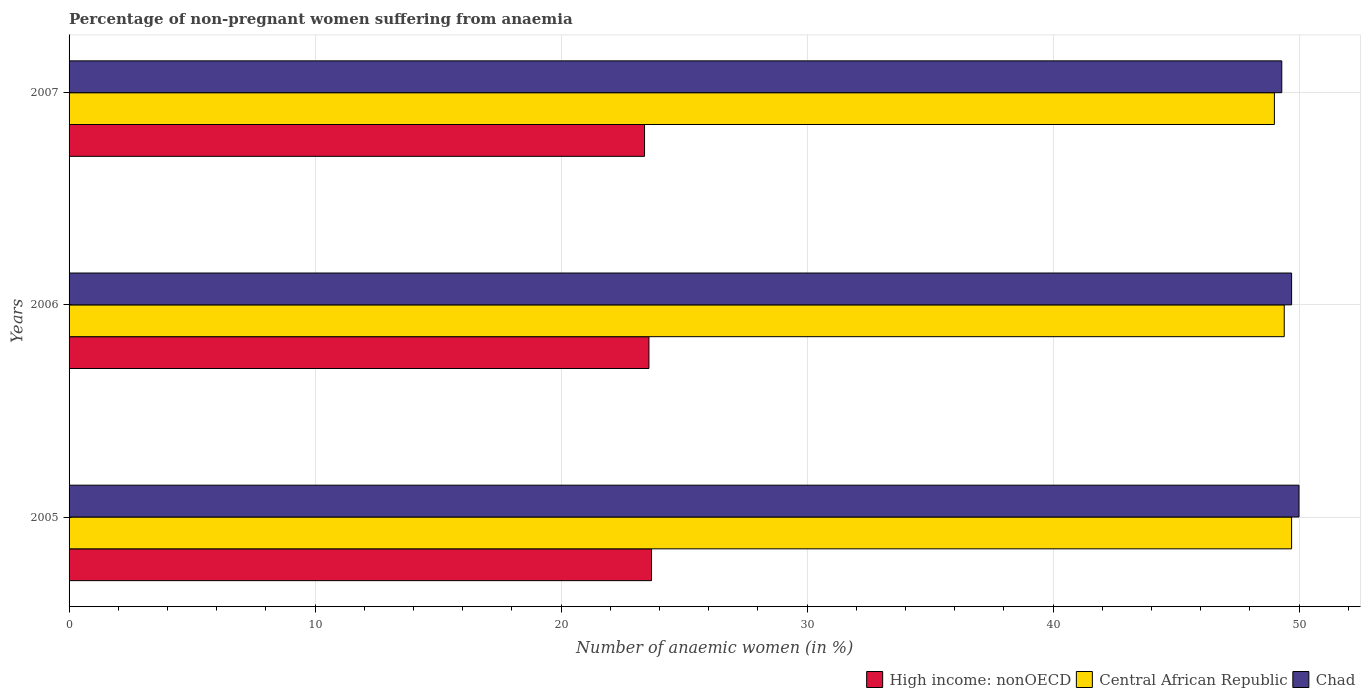How many different coloured bars are there?
Ensure brevity in your answer.  3. Are the number of bars per tick equal to the number of legend labels?
Provide a short and direct response. Yes. Are the number of bars on each tick of the Y-axis equal?
Keep it short and to the point. Yes. How many bars are there on the 1st tick from the bottom?
Provide a succinct answer. 3. What is the percentage of non-pregnant women suffering from anaemia in Chad in 2007?
Ensure brevity in your answer.  49.3. Across all years, what is the maximum percentage of non-pregnant women suffering from anaemia in Central African Republic?
Your answer should be compact. 49.7. Across all years, what is the minimum percentage of non-pregnant women suffering from anaemia in High income: nonOECD?
Ensure brevity in your answer.  23.39. What is the total percentage of non-pregnant women suffering from anaemia in Central African Republic in the graph?
Your response must be concise. 148.1. What is the difference between the percentage of non-pregnant women suffering from anaemia in High income: nonOECD in 2006 and that in 2007?
Ensure brevity in your answer.  0.18. What is the difference between the percentage of non-pregnant women suffering from anaemia in Central African Republic in 2006 and the percentage of non-pregnant women suffering from anaemia in High income: nonOECD in 2007?
Give a very brief answer. 26.01. What is the average percentage of non-pregnant women suffering from anaemia in Chad per year?
Make the answer very short. 49.67. In the year 2007, what is the difference between the percentage of non-pregnant women suffering from anaemia in Chad and percentage of non-pregnant women suffering from anaemia in High income: nonOECD?
Keep it short and to the point. 25.91. What is the ratio of the percentage of non-pregnant women suffering from anaemia in High income: nonOECD in 2005 to that in 2007?
Your answer should be compact. 1.01. What is the difference between the highest and the second highest percentage of non-pregnant women suffering from anaemia in High income: nonOECD?
Offer a terse response. 0.11. What is the difference between the highest and the lowest percentage of non-pregnant women suffering from anaemia in Central African Republic?
Keep it short and to the point. 0.7. In how many years, is the percentage of non-pregnant women suffering from anaemia in Central African Republic greater than the average percentage of non-pregnant women suffering from anaemia in Central African Republic taken over all years?
Provide a short and direct response. 2. Is the sum of the percentage of non-pregnant women suffering from anaemia in Central African Republic in 2006 and 2007 greater than the maximum percentage of non-pregnant women suffering from anaemia in High income: nonOECD across all years?
Ensure brevity in your answer.  Yes. What does the 1st bar from the top in 2005 represents?
Make the answer very short. Chad. What does the 2nd bar from the bottom in 2005 represents?
Provide a succinct answer. Central African Republic. Is it the case that in every year, the sum of the percentage of non-pregnant women suffering from anaemia in High income: nonOECD and percentage of non-pregnant women suffering from anaemia in Central African Republic is greater than the percentage of non-pregnant women suffering from anaemia in Chad?
Offer a very short reply. Yes. Are all the bars in the graph horizontal?
Offer a terse response. Yes. How many years are there in the graph?
Your response must be concise. 3. What is the difference between two consecutive major ticks on the X-axis?
Give a very brief answer. 10. How many legend labels are there?
Ensure brevity in your answer.  3. What is the title of the graph?
Ensure brevity in your answer.  Percentage of non-pregnant women suffering from anaemia. What is the label or title of the X-axis?
Offer a very short reply. Number of anaemic women (in %). What is the label or title of the Y-axis?
Your response must be concise. Years. What is the Number of anaemic women (in %) in High income: nonOECD in 2005?
Your answer should be compact. 23.68. What is the Number of anaemic women (in %) of Central African Republic in 2005?
Ensure brevity in your answer.  49.7. What is the Number of anaemic women (in %) in Chad in 2005?
Make the answer very short. 50. What is the Number of anaemic women (in %) of High income: nonOECD in 2006?
Keep it short and to the point. 23.57. What is the Number of anaemic women (in %) in Central African Republic in 2006?
Provide a succinct answer. 49.4. What is the Number of anaemic women (in %) in Chad in 2006?
Make the answer very short. 49.7. What is the Number of anaemic women (in %) in High income: nonOECD in 2007?
Ensure brevity in your answer.  23.39. What is the Number of anaemic women (in %) of Chad in 2007?
Offer a terse response. 49.3. Across all years, what is the maximum Number of anaemic women (in %) of High income: nonOECD?
Provide a short and direct response. 23.68. Across all years, what is the maximum Number of anaemic women (in %) of Central African Republic?
Offer a very short reply. 49.7. Across all years, what is the maximum Number of anaemic women (in %) in Chad?
Keep it short and to the point. 50. Across all years, what is the minimum Number of anaemic women (in %) of High income: nonOECD?
Ensure brevity in your answer.  23.39. Across all years, what is the minimum Number of anaemic women (in %) of Chad?
Your answer should be compact. 49.3. What is the total Number of anaemic women (in %) in High income: nonOECD in the graph?
Make the answer very short. 70.65. What is the total Number of anaemic women (in %) in Central African Republic in the graph?
Offer a terse response. 148.1. What is the total Number of anaemic women (in %) in Chad in the graph?
Offer a very short reply. 149. What is the difference between the Number of anaemic women (in %) in High income: nonOECD in 2005 and that in 2006?
Provide a short and direct response. 0.11. What is the difference between the Number of anaemic women (in %) in High income: nonOECD in 2005 and that in 2007?
Make the answer very short. 0.28. What is the difference between the Number of anaemic women (in %) of Chad in 2005 and that in 2007?
Offer a very short reply. 0.7. What is the difference between the Number of anaemic women (in %) in High income: nonOECD in 2006 and that in 2007?
Your answer should be very brief. 0.18. What is the difference between the Number of anaemic women (in %) in Central African Republic in 2006 and that in 2007?
Provide a succinct answer. 0.4. What is the difference between the Number of anaemic women (in %) of High income: nonOECD in 2005 and the Number of anaemic women (in %) of Central African Republic in 2006?
Provide a short and direct response. -25.72. What is the difference between the Number of anaemic women (in %) in High income: nonOECD in 2005 and the Number of anaemic women (in %) in Chad in 2006?
Your answer should be compact. -26.02. What is the difference between the Number of anaemic women (in %) in High income: nonOECD in 2005 and the Number of anaemic women (in %) in Central African Republic in 2007?
Make the answer very short. -25.32. What is the difference between the Number of anaemic women (in %) in High income: nonOECD in 2005 and the Number of anaemic women (in %) in Chad in 2007?
Keep it short and to the point. -25.62. What is the difference between the Number of anaemic women (in %) in High income: nonOECD in 2006 and the Number of anaemic women (in %) in Central African Republic in 2007?
Make the answer very short. -25.43. What is the difference between the Number of anaemic women (in %) of High income: nonOECD in 2006 and the Number of anaemic women (in %) of Chad in 2007?
Offer a very short reply. -25.73. What is the difference between the Number of anaemic women (in %) in Central African Republic in 2006 and the Number of anaemic women (in %) in Chad in 2007?
Your response must be concise. 0.1. What is the average Number of anaemic women (in %) of High income: nonOECD per year?
Your answer should be very brief. 23.55. What is the average Number of anaemic women (in %) of Central African Republic per year?
Your answer should be very brief. 49.37. What is the average Number of anaemic women (in %) in Chad per year?
Provide a short and direct response. 49.67. In the year 2005, what is the difference between the Number of anaemic women (in %) of High income: nonOECD and Number of anaemic women (in %) of Central African Republic?
Provide a short and direct response. -26.02. In the year 2005, what is the difference between the Number of anaemic women (in %) in High income: nonOECD and Number of anaemic women (in %) in Chad?
Your answer should be compact. -26.32. In the year 2005, what is the difference between the Number of anaemic women (in %) in Central African Republic and Number of anaemic women (in %) in Chad?
Provide a short and direct response. -0.3. In the year 2006, what is the difference between the Number of anaemic women (in %) in High income: nonOECD and Number of anaemic women (in %) in Central African Republic?
Offer a terse response. -25.83. In the year 2006, what is the difference between the Number of anaemic women (in %) in High income: nonOECD and Number of anaemic women (in %) in Chad?
Give a very brief answer. -26.13. In the year 2006, what is the difference between the Number of anaemic women (in %) of Central African Republic and Number of anaemic women (in %) of Chad?
Provide a short and direct response. -0.3. In the year 2007, what is the difference between the Number of anaemic women (in %) in High income: nonOECD and Number of anaemic women (in %) in Central African Republic?
Your response must be concise. -25.61. In the year 2007, what is the difference between the Number of anaemic women (in %) in High income: nonOECD and Number of anaemic women (in %) in Chad?
Offer a very short reply. -25.91. In the year 2007, what is the difference between the Number of anaemic women (in %) in Central African Republic and Number of anaemic women (in %) in Chad?
Your answer should be compact. -0.3. What is the ratio of the Number of anaemic women (in %) in High income: nonOECD in 2005 to that in 2006?
Offer a terse response. 1. What is the ratio of the Number of anaemic women (in %) of Chad in 2005 to that in 2006?
Your response must be concise. 1.01. What is the ratio of the Number of anaemic women (in %) in High income: nonOECD in 2005 to that in 2007?
Offer a terse response. 1.01. What is the ratio of the Number of anaemic women (in %) in Central African Republic in 2005 to that in 2007?
Provide a short and direct response. 1.01. What is the ratio of the Number of anaemic women (in %) of Chad in 2005 to that in 2007?
Offer a terse response. 1.01. What is the ratio of the Number of anaemic women (in %) in High income: nonOECD in 2006 to that in 2007?
Provide a succinct answer. 1.01. What is the ratio of the Number of anaemic women (in %) of Central African Republic in 2006 to that in 2007?
Your answer should be very brief. 1.01. What is the difference between the highest and the second highest Number of anaemic women (in %) in High income: nonOECD?
Offer a terse response. 0.11. What is the difference between the highest and the lowest Number of anaemic women (in %) in High income: nonOECD?
Your answer should be very brief. 0.28. What is the difference between the highest and the lowest Number of anaemic women (in %) of Central African Republic?
Ensure brevity in your answer.  0.7. What is the difference between the highest and the lowest Number of anaemic women (in %) of Chad?
Keep it short and to the point. 0.7. 